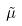Convert formula to latex. <formula><loc_0><loc_0><loc_500><loc_500>\tilde { \mu }</formula> 